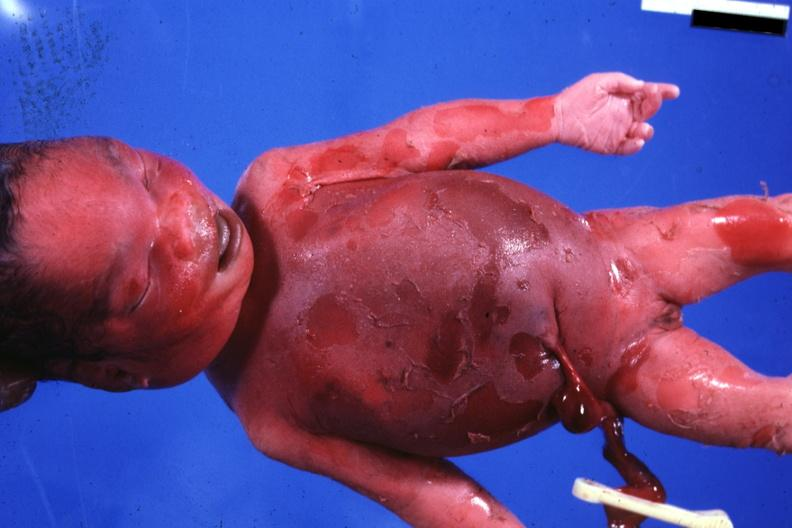s stillborn macerated present?
Answer the question using a single word or phrase. Yes 